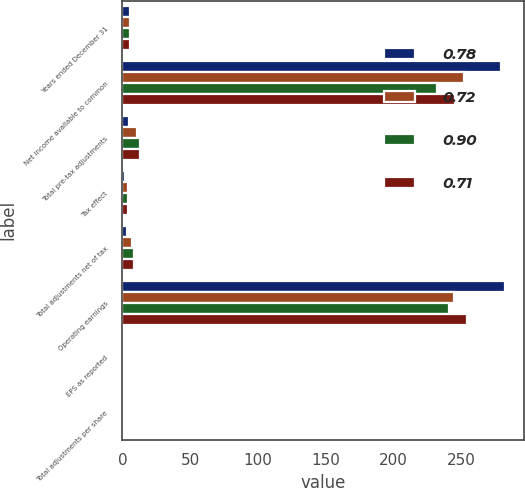Convert chart to OTSL. <chart><loc_0><loc_0><loc_500><loc_500><stacked_bar_chart><ecel><fcel>Years ended December 31<fcel>Net income available to common<fcel>Total pre-tax adjustments<fcel>Tax effect<fcel>Total adjustments net of tax<fcel>Operating earnings<fcel>EPS as reported<fcel>Total adjustments per share<nl><fcel>0.78<fcel>5.95<fcel>279.2<fcel>4.7<fcel>1.6<fcel>3.1<fcel>282.3<fcel>0.92<fcel>0.01<nl><fcel>0.72<fcel>5.95<fcel>251.7<fcel>11.1<fcel>3.9<fcel>7.2<fcel>244.5<fcel>0.84<fcel>0.02<nl><fcel>0.9<fcel>5.95<fcel>232.4<fcel>12.7<fcel>4<fcel>8.7<fcel>241.1<fcel>0.74<fcel>0.03<nl><fcel>0.71<fcel>5.95<fcel>245.3<fcel>12.7<fcel>4.1<fcel>8.6<fcel>253.9<fcel>0.72<fcel>0.03<nl></chart> 